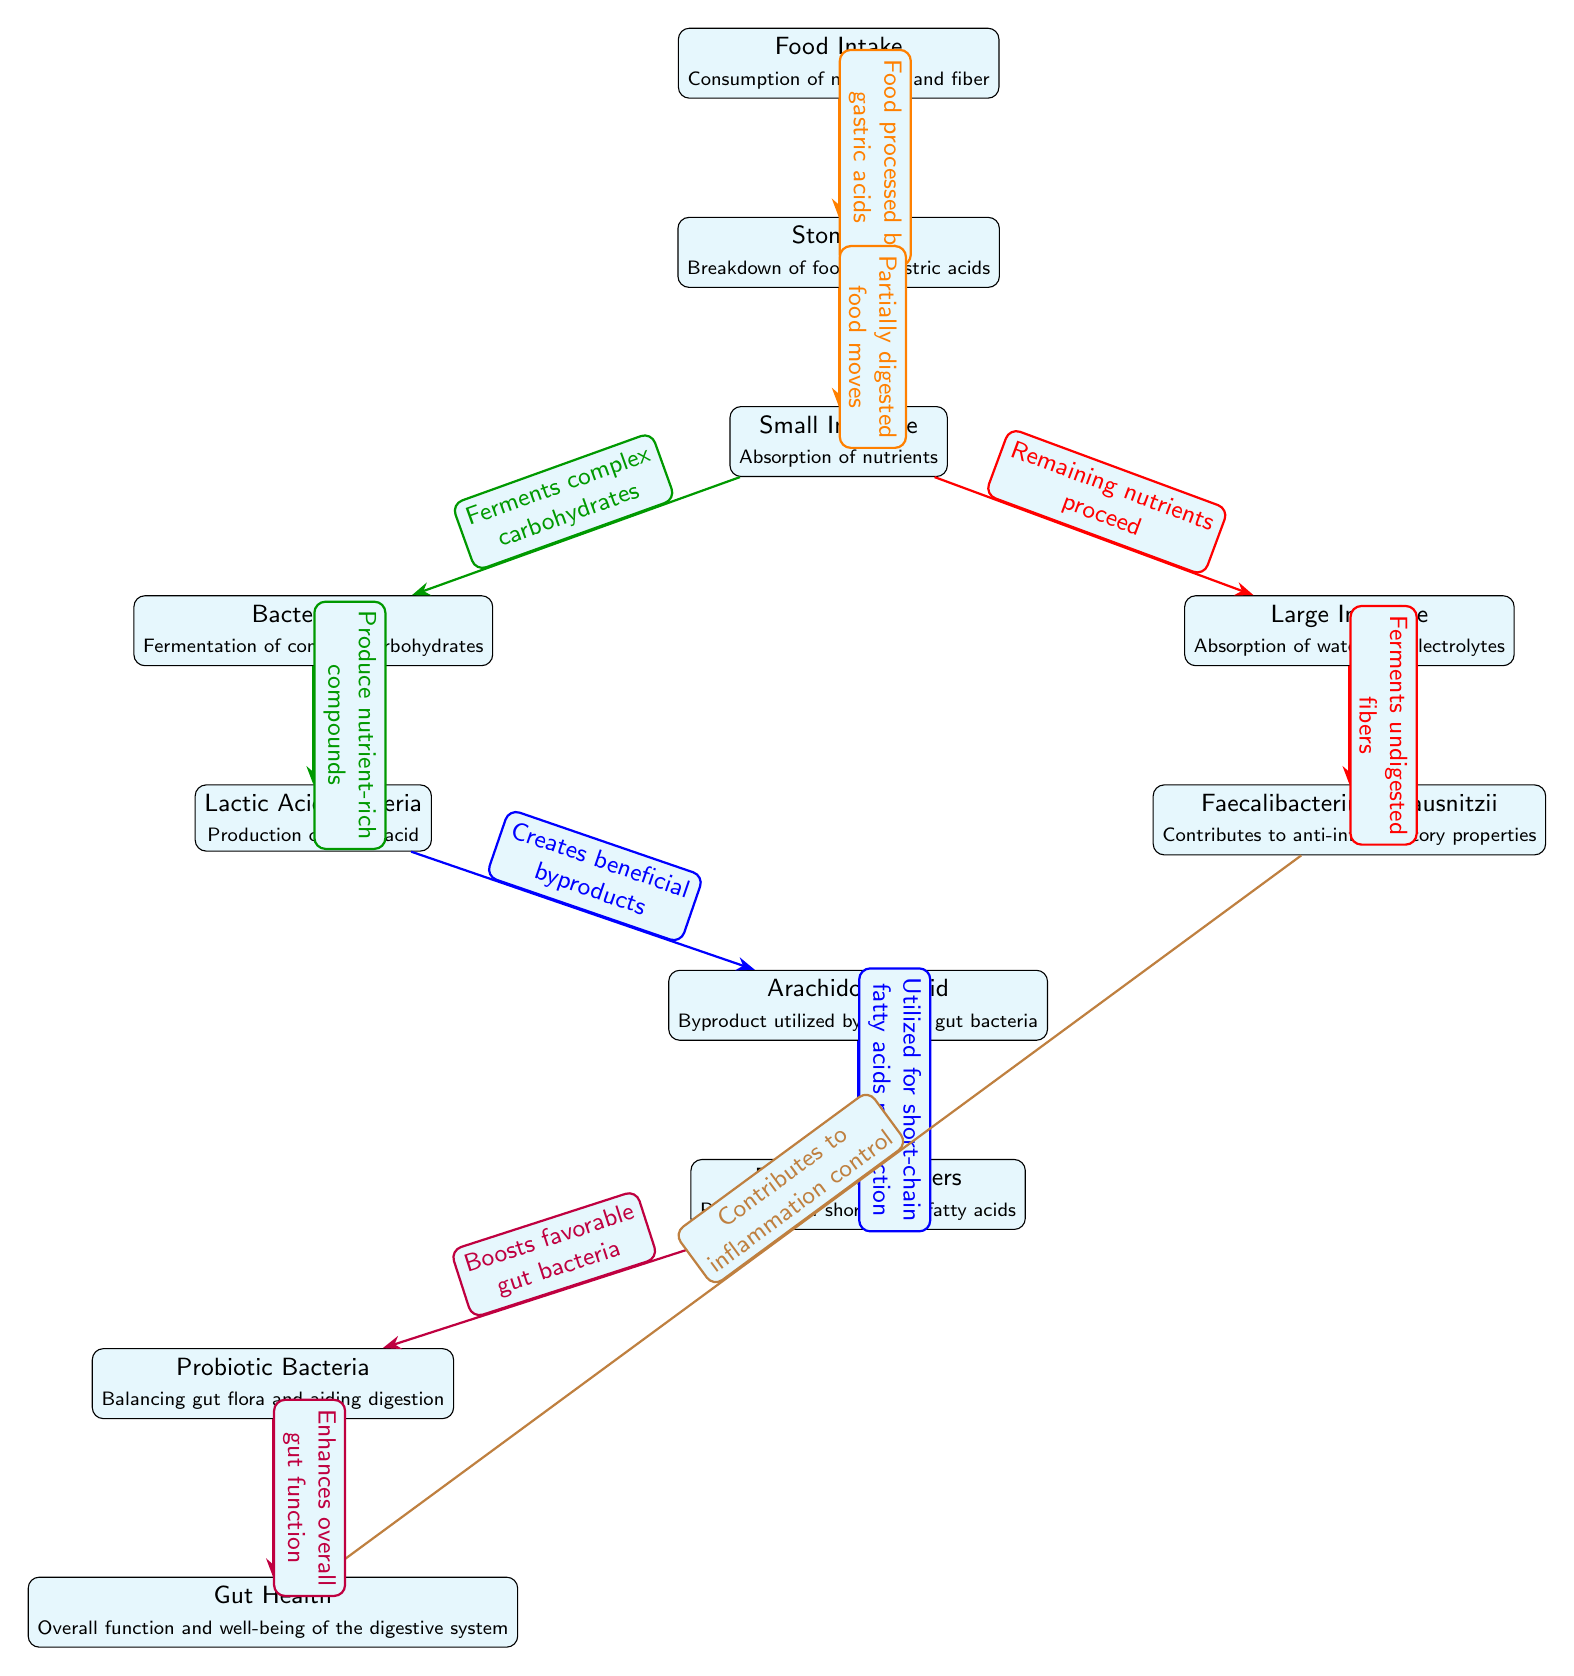What is the first step in the food chain? The first node in the diagram is "Food Intake," which indicates the beginning of the process where nutrients and fiber are consumed.
Answer: Food Intake How many bacteria types are mentioned in the diagram? There are four types of bacteria shown: Bacteroides, Lactic Acid Bacteria, Butyrate Producers, and Probiotic Bacteria.
Answer: Four What does the stomach do in the food chain? The stomach's function in the diagram is to break down food using gastric acids, as indicated in its description.
Answer: Breakdown of food by gastric acids What do butyrate producers produce? The description of the "Butyrate Producers" node states that they produce short-chain fatty acids, which are beneficial compounds.
Answer: Short-chain fatty acids What role does Faecalibacterium prausnitzii play in gut health? The diagram shows that Faecalibacterium prausnitzii contributes to inflammation control, affecting overall gut health positively.
Answer: Inflammation control How does probiotic bacteria affect gut health? Probiotic Bacteria enhances overall gut function, as indicated by the flow from the Probiotic Bacteria node to the Gut Health node.
Answer: Enhances overall gut function What nutrient moves from the small intestine to the large intestine? The remaining nutrients, as described in the edge connecting these two nodes, proceed from the Small Intestine to the Large Intestine.
Answer: Remaining nutrients Which bacteria type ferments undigested fibers in the large intestine? The diagram indicates that Faecalibacterium prausnitzii ferments the undigested fibers present in the Large Intestine.
Answer: Faecalibacterium prausnitzii What is a byproduct of lactic acid bacteria processing? Lactic Acid Bacteria creates beneficial byproducts, specifically mentioned as arachidonic acid, which is utilized by other gut bacteria.
Answer: Arachidonic Acid 